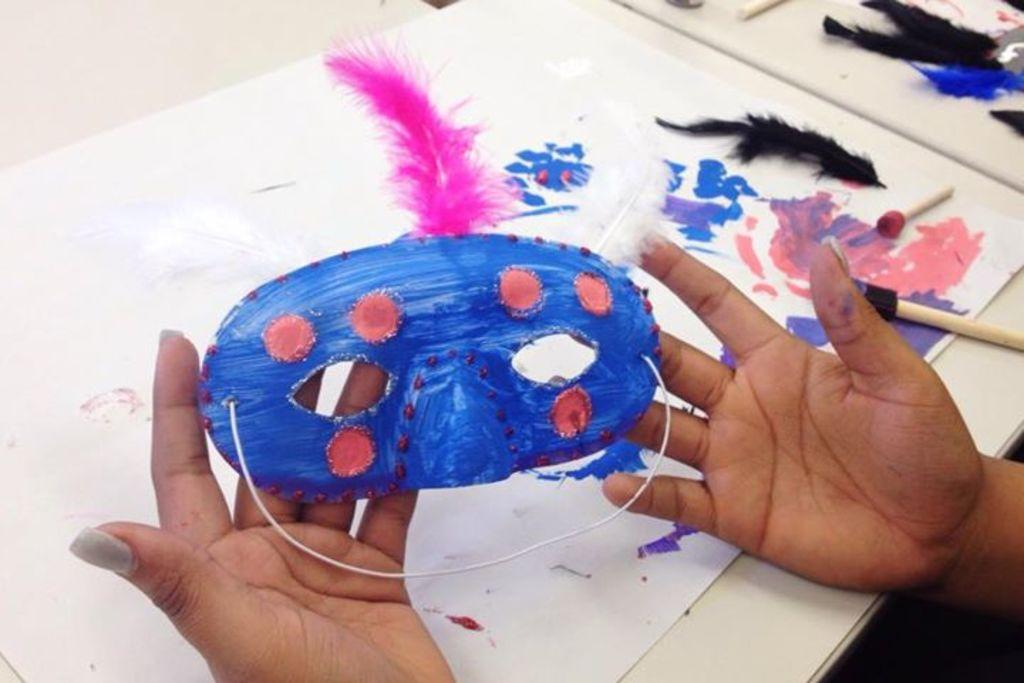Who is present in the image? There is a person in the image. What is the person holding? The person is holding a mask. What can be seen on the table in the image? There is a table in the image with a paper, a feather, and brushes on it. What is the air quality like in the image? The provided facts do not mention anything about air quality, so it cannot be determined from the image. 